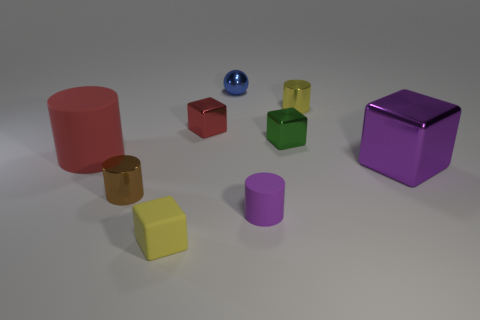Do the purple thing left of the tiny green block and the brown metal thing have the same shape?
Give a very brief answer. Yes. How many other yellow matte objects have the same shape as the tiny yellow matte object?
Provide a short and direct response. 0. Are there any purple blocks made of the same material as the brown cylinder?
Offer a very short reply. Yes. There is a tiny thing that is behind the cylinder that is behind the tiny red cube; what is its material?
Keep it short and to the point. Metal. How big is the metallic cube left of the small purple matte cylinder?
Provide a succinct answer. Small. Is the color of the large matte cylinder the same as the small metallic thing that is in front of the red cylinder?
Your answer should be compact. No. Are there any large cubes that have the same color as the tiny matte cube?
Offer a very short reply. No. Does the red block have the same material as the tiny yellow object behind the red rubber cylinder?
Your answer should be very brief. Yes. How many tiny objects are brown metallic cylinders or blue shiny things?
Give a very brief answer. 2. There is a cylinder that is the same color as the tiny rubber cube; what is it made of?
Give a very brief answer. Metal. 